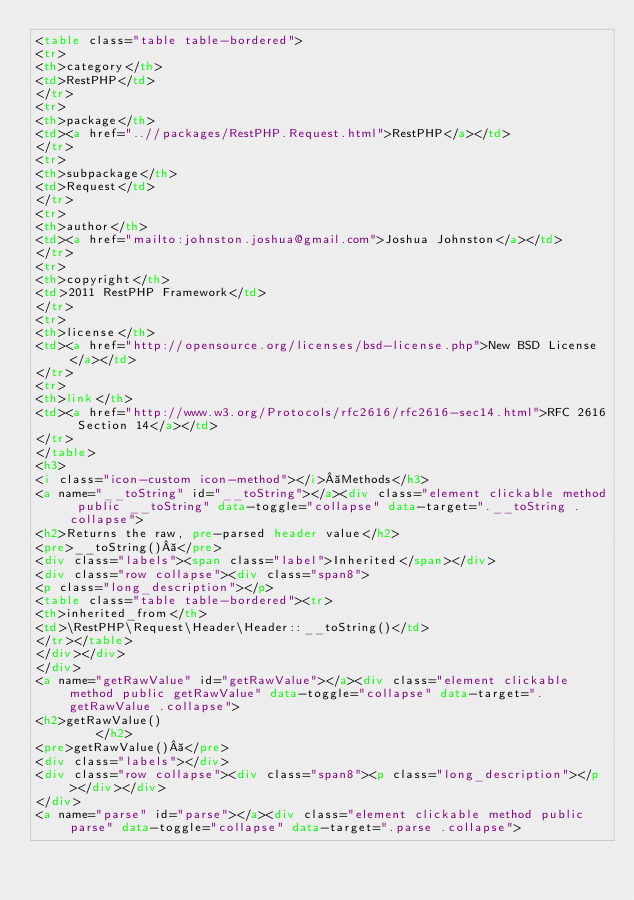Convert code to text. <code><loc_0><loc_0><loc_500><loc_500><_HTML_><table class="table table-bordered">
<tr>
<th>category</th>
<td>RestPHP</td>
</tr>
<tr>
<th>package</th>
<td><a href="..//packages/RestPHP.Request.html">RestPHP</a></td>
</tr>
<tr>
<th>subpackage</th>
<td>Request</td>
</tr>
<tr>
<th>author</th>
<td><a href="mailto:johnston.joshua@gmail.com">Joshua Johnston</a></td>
</tr>
<tr>
<th>copyright</th>
<td>2011 RestPHP Framework</td>
</tr>
<tr>
<th>license</th>
<td><a href="http://opensource.org/licenses/bsd-license.php">New BSD License</a></td>
</tr>
<tr>
<th>link</th>
<td><a href="http://www.w3.org/Protocols/rfc2616/rfc2616-sec14.html">RFC 2616 Section 14</a></td>
</tr>
</table>
<h3>
<i class="icon-custom icon-method"></i> Methods</h3>
<a name="__toString" id="__toString"></a><div class="element clickable method public __toString" data-toggle="collapse" data-target=".__toString .collapse">
<h2>Returns the raw, pre-parsed header value</h2>
<pre>__toString() </pre>
<div class="labels"><span class="label">Inherited</span></div>
<div class="row collapse"><div class="span8">
<p class="long_description"></p>
<table class="table table-bordered"><tr>
<th>inherited_from</th>
<td>\RestPHP\Request\Header\Header::__toString()</td>
</tr></table>
</div></div>
</div>
<a name="getRawValue" id="getRawValue"></a><div class="element clickable method public getRawValue" data-toggle="collapse" data-target=".getRawValue .collapse">
<h2>getRawValue()
        </h2>
<pre>getRawValue() </pre>
<div class="labels"></div>
<div class="row collapse"><div class="span8"><p class="long_description"></p></div></div>
</div>
<a name="parse" id="parse"></a><div class="element clickable method public parse" data-toggle="collapse" data-target=".parse .collapse"></code> 